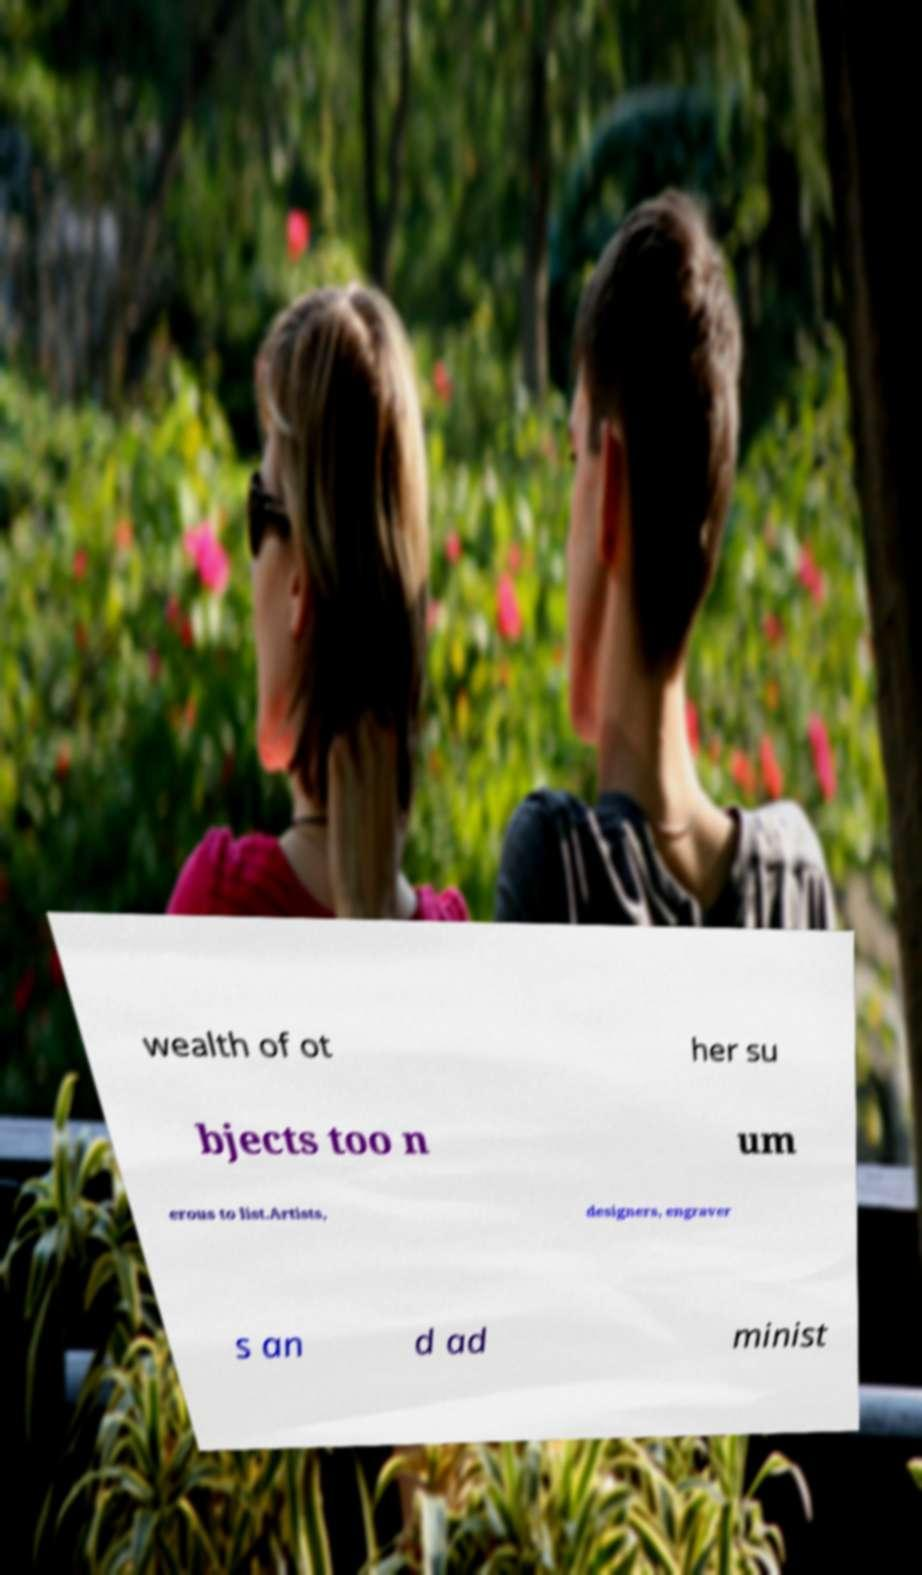Could you extract and type out the text from this image? wealth of ot her su bjects too n um erous to list.Artists, designers, engraver s an d ad minist 